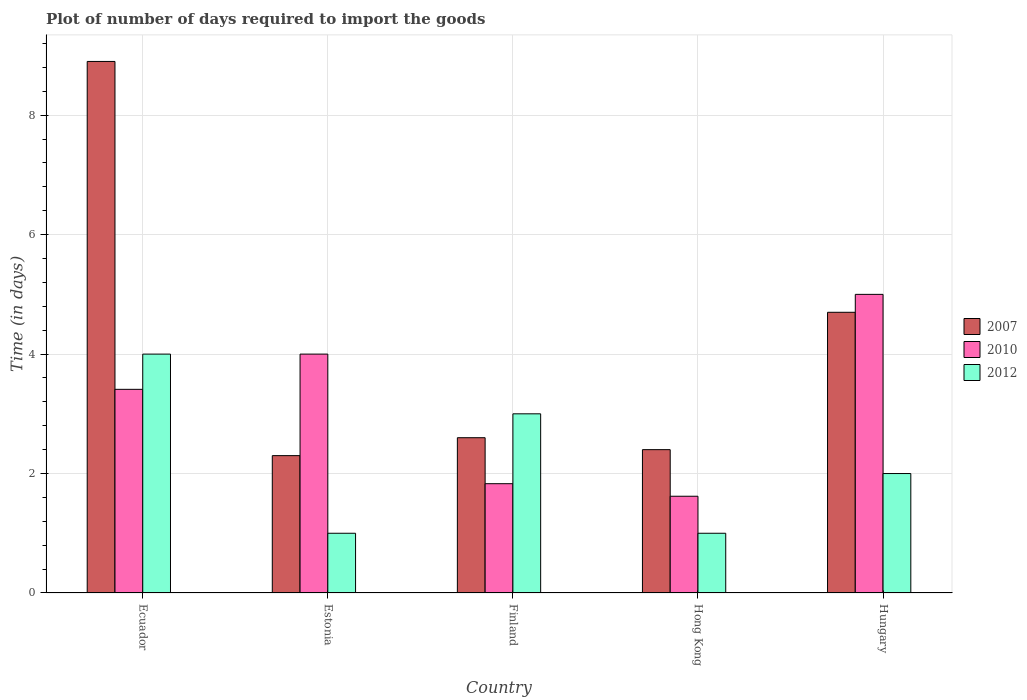How many bars are there on the 4th tick from the left?
Your response must be concise. 3. What is the label of the 1st group of bars from the left?
Provide a succinct answer. Ecuador. In how many cases, is the number of bars for a given country not equal to the number of legend labels?
Keep it short and to the point. 0. What is the time required to import goods in 2010 in Estonia?
Offer a terse response. 4. In which country was the time required to import goods in 2007 maximum?
Keep it short and to the point. Ecuador. In which country was the time required to import goods in 2010 minimum?
Offer a terse response. Hong Kong. What is the total time required to import goods in 2010 in the graph?
Keep it short and to the point. 15.86. What is the difference between the time required to import goods in 2010 in Ecuador and that in Hong Kong?
Provide a succinct answer. 1.79. What is the average time required to import goods in 2007 per country?
Give a very brief answer. 4.18. What is the difference between the time required to import goods of/in 2010 and time required to import goods of/in 2012 in Ecuador?
Your response must be concise. -0.59. In how many countries, is the time required to import goods in 2007 greater than 5.6 days?
Offer a terse response. 1. What is the ratio of the time required to import goods in 2007 in Ecuador to that in Estonia?
Your response must be concise. 3.87. Is the time required to import goods in 2007 in Estonia less than that in Hungary?
Make the answer very short. Yes. What is the difference between the highest and the second highest time required to import goods in 2007?
Provide a succinct answer. 6.3. What is the difference between the highest and the lowest time required to import goods in 2012?
Give a very brief answer. 3. Is the sum of the time required to import goods in 2012 in Hong Kong and Hungary greater than the maximum time required to import goods in 2007 across all countries?
Offer a terse response. No. What does the 1st bar from the left in Hong Kong represents?
Your response must be concise. 2007. How many bars are there?
Give a very brief answer. 15. What is the difference between two consecutive major ticks on the Y-axis?
Provide a succinct answer. 2. What is the title of the graph?
Your answer should be compact. Plot of number of days required to import the goods. What is the label or title of the X-axis?
Make the answer very short. Country. What is the label or title of the Y-axis?
Keep it short and to the point. Time (in days). What is the Time (in days) of 2010 in Ecuador?
Give a very brief answer. 3.41. What is the Time (in days) of 2012 in Ecuador?
Ensure brevity in your answer.  4. What is the Time (in days) of 2007 in Estonia?
Offer a terse response. 2.3. What is the Time (in days) in 2010 in Estonia?
Provide a succinct answer. 4. What is the Time (in days) in 2012 in Estonia?
Provide a succinct answer. 1. What is the Time (in days) in 2010 in Finland?
Your answer should be compact. 1.83. What is the Time (in days) of 2012 in Finland?
Make the answer very short. 3. What is the Time (in days) of 2010 in Hong Kong?
Give a very brief answer. 1.62. What is the Time (in days) in 2012 in Hong Kong?
Provide a succinct answer. 1. What is the Time (in days) of 2007 in Hungary?
Ensure brevity in your answer.  4.7. What is the Time (in days) in 2010 in Hungary?
Provide a short and direct response. 5. Across all countries, what is the maximum Time (in days) in 2012?
Keep it short and to the point. 4. Across all countries, what is the minimum Time (in days) in 2010?
Offer a very short reply. 1.62. What is the total Time (in days) in 2007 in the graph?
Ensure brevity in your answer.  20.9. What is the total Time (in days) in 2010 in the graph?
Your answer should be compact. 15.86. What is the total Time (in days) in 2012 in the graph?
Offer a terse response. 11. What is the difference between the Time (in days) of 2010 in Ecuador and that in Estonia?
Your response must be concise. -0.59. What is the difference between the Time (in days) in 2007 in Ecuador and that in Finland?
Your answer should be very brief. 6.3. What is the difference between the Time (in days) in 2010 in Ecuador and that in Finland?
Give a very brief answer. 1.58. What is the difference between the Time (in days) in 2007 in Ecuador and that in Hong Kong?
Offer a very short reply. 6.5. What is the difference between the Time (in days) in 2010 in Ecuador and that in Hong Kong?
Your answer should be very brief. 1.79. What is the difference between the Time (in days) of 2010 in Ecuador and that in Hungary?
Your answer should be very brief. -1.59. What is the difference between the Time (in days) of 2012 in Ecuador and that in Hungary?
Provide a succinct answer. 2. What is the difference between the Time (in days) in 2010 in Estonia and that in Finland?
Your response must be concise. 2.17. What is the difference between the Time (in days) of 2010 in Estonia and that in Hong Kong?
Offer a very short reply. 2.38. What is the difference between the Time (in days) in 2010 in Estonia and that in Hungary?
Your answer should be very brief. -1. What is the difference between the Time (in days) of 2012 in Estonia and that in Hungary?
Give a very brief answer. -1. What is the difference between the Time (in days) of 2010 in Finland and that in Hong Kong?
Keep it short and to the point. 0.21. What is the difference between the Time (in days) of 2010 in Finland and that in Hungary?
Ensure brevity in your answer.  -3.17. What is the difference between the Time (in days) of 2012 in Finland and that in Hungary?
Make the answer very short. 1. What is the difference between the Time (in days) in 2010 in Hong Kong and that in Hungary?
Provide a succinct answer. -3.38. What is the difference between the Time (in days) of 2010 in Ecuador and the Time (in days) of 2012 in Estonia?
Your answer should be very brief. 2.41. What is the difference between the Time (in days) in 2007 in Ecuador and the Time (in days) in 2010 in Finland?
Offer a terse response. 7.07. What is the difference between the Time (in days) in 2010 in Ecuador and the Time (in days) in 2012 in Finland?
Ensure brevity in your answer.  0.41. What is the difference between the Time (in days) in 2007 in Ecuador and the Time (in days) in 2010 in Hong Kong?
Your answer should be very brief. 7.28. What is the difference between the Time (in days) in 2007 in Ecuador and the Time (in days) in 2012 in Hong Kong?
Your answer should be compact. 7.9. What is the difference between the Time (in days) of 2010 in Ecuador and the Time (in days) of 2012 in Hong Kong?
Ensure brevity in your answer.  2.41. What is the difference between the Time (in days) of 2007 in Ecuador and the Time (in days) of 2010 in Hungary?
Keep it short and to the point. 3.9. What is the difference between the Time (in days) in 2010 in Ecuador and the Time (in days) in 2012 in Hungary?
Provide a short and direct response. 1.41. What is the difference between the Time (in days) of 2007 in Estonia and the Time (in days) of 2010 in Finland?
Ensure brevity in your answer.  0.47. What is the difference between the Time (in days) in 2007 in Estonia and the Time (in days) in 2010 in Hong Kong?
Ensure brevity in your answer.  0.68. What is the difference between the Time (in days) of 2007 in Estonia and the Time (in days) of 2010 in Hungary?
Offer a terse response. -2.7. What is the difference between the Time (in days) of 2010 in Estonia and the Time (in days) of 2012 in Hungary?
Provide a succinct answer. 2. What is the difference between the Time (in days) in 2007 in Finland and the Time (in days) in 2010 in Hong Kong?
Offer a terse response. 0.98. What is the difference between the Time (in days) in 2007 in Finland and the Time (in days) in 2012 in Hong Kong?
Make the answer very short. 1.6. What is the difference between the Time (in days) in 2010 in Finland and the Time (in days) in 2012 in Hong Kong?
Ensure brevity in your answer.  0.83. What is the difference between the Time (in days) in 2007 in Finland and the Time (in days) in 2010 in Hungary?
Provide a short and direct response. -2.4. What is the difference between the Time (in days) of 2007 in Finland and the Time (in days) of 2012 in Hungary?
Provide a short and direct response. 0.6. What is the difference between the Time (in days) in 2010 in Finland and the Time (in days) in 2012 in Hungary?
Provide a succinct answer. -0.17. What is the difference between the Time (in days) of 2010 in Hong Kong and the Time (in days) of 2012 in Hungary?
Offer a very short reply. -0.38. What is the average Time (in days) in 2007 per country?
Ensure brevity in your answer.  4.18. What is the average Time (in days) in 2010 per country?
Keep it short and to the point. 3.17. What is the average Time (in days) in 2012 per country?
Offer a terse response. 2.2. What is the difference between the Time (in days) of 2007 and Time (in days) of 2010 in Ecuador?
Offer a terse response. 5.49. What is the difference between the Time (in days) in 2007 and Time (in days) in 2012 in Ecuador?
Keep it short and to the point. 4.9. What is the difference between the Time (in days) in 2010 and Time (in days) in 2012 in Ecuador?
Your response must be concise. -0.59. What is the difference between the Time (in days) of 2007 and Time (in days) of 2010 in Estonia?
Offer a terse response. -1.7. What is the difference between the Time (in days) of 2007 and Time (in days) of 2012 in Estonia?
Offer a terse response. 1.3. What is the difference between the Time (in days) in 2010 and Time (in days) in 2012 in Estonia?
Keep it short and to the point. 3. What is the difference between the Time (in days) in 2007 and Time (in days) in 2010 in Finland?
Provide a short and direct response. 0.77. What is the difference between the Time (in days) in 2007 and Time (in days) in 2012 in Finland?
Make the answer very short. -0.4. What is the difference between the Time (in days) of 2010 and Time (in days) of 2012 in Finland?
Offer a terse response. -1.17. What is the difference between the Time (in days) in 2007 and Time (in days) in 2010 in Hong Kong?
Provide a short and direct response. 0.78. What is the difference between the Time (in days) in 2010 and Time (in days) in 2012 in Hong Kong?
Make the answer very short. 0.62. What is the difference between the Time (in days) of 2007 and Time (in days) of 2010 in Hungary?
Keep it short and to the point. -0.3. What is the difference between the Time (in days) of 2010 and Time (in days) of 2012 in Hungary?
Offer a very short reply. 3. What is the ratio of the Time (in days) of 2007 in Ecuador to that in Estonia?
Offer a terse response. 3.87. What is the ratio of the Time (in days) of 2010 in Ecuador to that in Estonia?
Offer a very short reply. 0.85. What is the ratio of the Time (in days) of 2007 in Ecuador to that in Finland?
Offer a terse response. 3.42. What is the ratio of the Time (in days) in 2010 in Ecuador to that in Finland?
Keep it short and to the point. 1.86. What is the ratio of the Time (in days) of 2007 in Ecuador to that in Hong Kong?
Ensure brevity in your answer.  3.71. What is the ratio of the Time (in days) in 2010 in Ecuador to that in Hong Kong?
Your answer should be compact. 2.1. What is the ratio of the Time (in days) of 2012 in Ecuador to that in Hong Kong?
Make the answer very short. 4. What is the ratio of the Time (in days) in 2007 in Ecuador to that in Hungary?
Ensure brevity in your answer.  1.89. What is the ratio of the Time (in days) in 2010 in Ecuador to that in Hungary?
Your answer should be very brief. 0.68. What is the ratio of the Time (in days) of 2012 in Ecuador to that in Hungary?
Offer a terse response. 2. What is the ratio of the Time (in days) in 2007 in Estonia to that in Finland?
Offer a very short reply. 0.88. What is the ratio of the Time (in days) of 2010 in Estonia to that in Finland?
Give a very brief answer. 2.19. What is the ratio of the Time (in days) of 2010 in Estonia to that in Hong Kong?
Ensure brevity in your answer.  2.47. What is the ratio of the Time (in days) of 2012 in Estonia to that in Hong Kong?
Provide a succinct answer. 1. What is the ratio of the Time (in days) of 2007 in Estonia to that in Hungary?
Provide a succinct answer. 0.49. What is the ratio of the Time (in days) of 2010 in Estonia to that in Hungary?
Provide a short and direct response. 0.8. What is the ratio of the Time (in days) of 2012 in Estonia to that in Hungary?
Give a very brief answer. 0.5. What is the ratio of the Time (in days) of 2010 in Finland to that in Hong Kong?
Provide a short and direct response. 1.13. What is the ratio of the Time (in days) of 2012 in Finland to that in Hong Kong?
Give a very brief answer. 3. What is the ratio of the Time (in days) in 2007 in Finland to that in Hungary?
Your answer should be compact. 0.55. What is the ratio of the Time (in days) in 2010 in Finland to that in Hungary?
Offer a terse response. 0.37. What is the ratio of the Time (in days) in 2007 in Hong Kong to that in Hungary?
Offer a terse response. 0.51. What is the ratio of the Time (in days) of 2010 in Hong Kong to that in Hungary?
Provide a short and direct response. 0.32. What is the difference between the highest and the second highest Time (in days) in 2012?
Offer a terse response. 1. What is the difference between the highest and the lowest Time (in days) of 2007?
Offer a terse response. 6.6. What is the difference between the highest and the lowest Time (in days) of 2010?
Offer a very short reply. 3.38. What is the difference between the highest and the lowest Time (in days) in 2012?
Offer a very short reply. 3. 